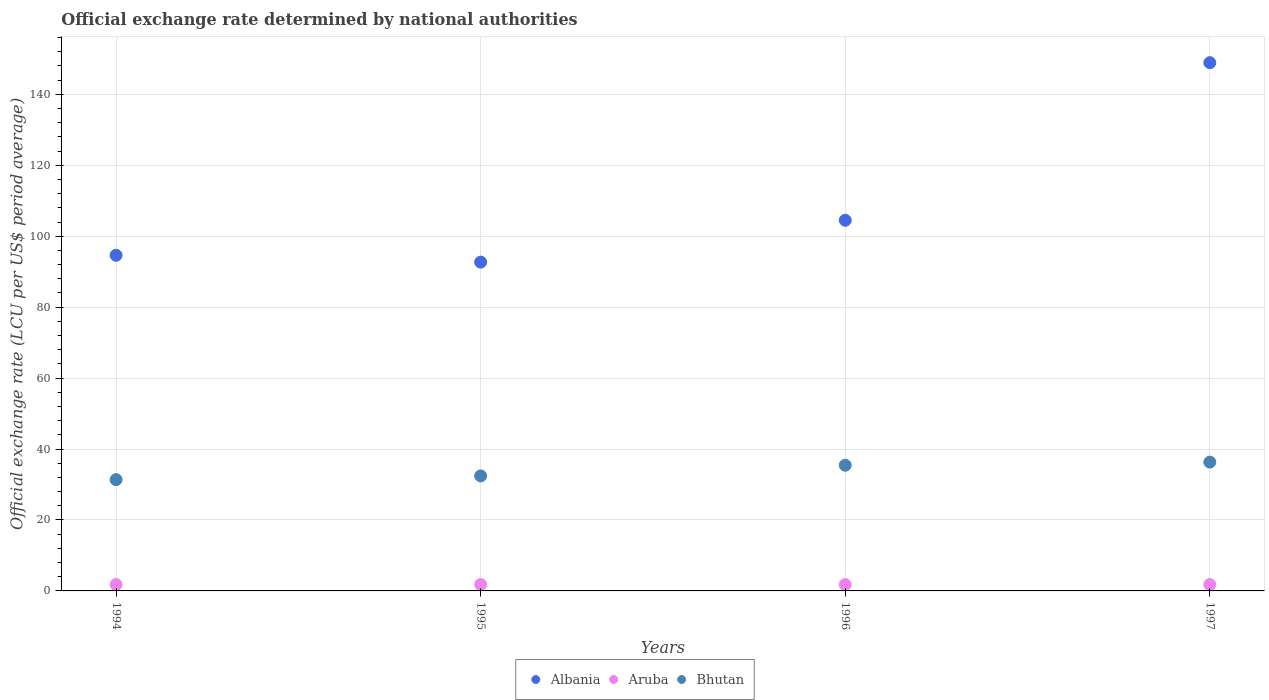How many different coloured dotlines are there?
Provide a succinct answer. 3. What is the official exchange rate in Aruba in 1997?
Your answer should be compact. 1.79. Across all years, what is the maximum official exchange rate in Bhutan?
Your response must be concise. 36.31. Across all years, what is the minimum official exchange rate in Aruba?
Your answer should be compact. 1.79. What is the total official exchange rate in Bhutan in the graph?
Offer a terse response. 135.55. What is the difference between the official exchange rate in Albania in 1995 and the official exchange rate in Aruba in 1996?
Offer a terse response. 90.91. What is the average official exchange rate in Bhutan per year?
Keep it short and to the point. 33.89. In the year 1996, what is the difference between the official exchange rate in Bhutan and official exchange rate in Albania?
Keep it short and to the point. -69.07. In how many years, is the official exchange rate in Bhutan greater than 8 LCU?
Provide a succinct answer. 4. What is the ratio of the official exchange rate in Albania in 1994 to that in 1996?
Your response must be concise. 0.91. Is the difference between the official exchange rate in Bhutan in 1994 and 1996 greater than the difference between the official exchange rate in Albania in 1994 and 1996?
Provide a short and direct response. Yes. What is the difference between the highest and the lowest official exchange rate in Albania?
Provide a succinct answer. 56.24. Is the official exchange rate in Aruba strictly less than the official exchange rate in Albania over the years?
Give a very brief answer. Yes. How many years are there in the graph?
Your answer should be very brief. 4. What is the difference between two consecutive major ticks on the Y-axis?
Your response must be concise. 20. Does the graph contain any zero values?
Offer a terse response. No. How are the legend labels stacked?
Your answer should be compact. Horizontal. What is the title of the graph?
Offer a very short reply. Official exchange rate determined by national authorities. Does "Mexico" appear as one of the legend labels in the graph?
Offer a very short reply. No. What is the label or title of the Y-axis?
Your response must be concise. Official exchange rate (LCU per US$ period average). What is the Official exchange rate (LCU per US$ period average) in Albania in 1994?
Ensure brevity in your answer.  94.62. What is the Official exchange rate (LCU per US$ period average) in Aruba in 1994?
Ensure brevity in your answer.  1.79. What is the Official exchange rate (LCU per US$ period average) of Bhutan in 1994?
Your answer should be compact. 31.37. What is the Official exchange rate (LCU per US$ period average) of Albania in 1995?
Provide a short and direct response. 92.7. What is the Official exchange rate (LCU per US$ period average) of Aruba in 1995?
Provide a succinct answer. 1.79. What is the Official exchange rate (LCU per US$ period average) of Bhutan in 1995?
Your response must be concise. 32.43. What is the Official exchange rate (LCU per US$ period average) of Albania in 1996?
Your response must be concise. 104.5. What is the Official exchange rate (LCU per US$ period average) in Aruba in 1996?
Your answer should be compact. 1.79. What is the Official exchange rate (LCU per US$ period average) in Bhutan in 1996?
Provide a short and direct response. 35.43. What is the Official exchange rate (LCU per US$ period average) in Albania in 1997?
Ensure brevity in your answer.  148.93. What is the Official exchange rate (LCU per US$ period average) of Aruba in 1997?
Give a very brief answer. 1.79. What is the Official exchange rate (LCU per US$ period average) of Bhutan in 1997?
Make the answer very short. 36.31. Across all years, what is the maximum Official exchange rate (LCU per US$ period average) in Albania?
Offer a very short reply. 148.93. Across all years, what is the maximum Official exchange rate (LCU per US$ period average) in Aruba?
Offer a very short reply. 1.79. Across all years, what is the maximum Official exchange rate (LCU per US$ period average) of Bhutan?
Make the answer very short. 36.31. Across all years, what is the minimum Official exchange rate (LCU per US$ period average) in Albania?
Provide a succinct answer. 92.7. Across all years, what is the minimum Official exchange rate (LCU per US$ period average) in Aruba?
Keep it short and to the point. 1.79. Across all years, what is the minimum Official exchange rate (LCU per US$ period average) in Bhutan?
Give a very brief answer. 31.37. What is the total Official exchange rate (LCU per US$ period average) in Albania in the graph?
Offer a terse response. 440.75. What is the total Official exchange rate (LCU per US$ period average) in Aruba in the graph?
Provide a short and direct response. 7.16. What is the total Official exchange rate (LCU per US$ period average) in Bhutan in the graph?
Your answer should be compact. 135.55. What is the difference between the Official exchange rate (LCU per US$ period average) of Albania in 1994 and that in 1995?
Offer a very short reply. 1.93. What is the difference between the Official exchange rate (LCU per US$ period average) of Bhutan in 1994 and that in 1995?
Offer a very short reply. -1.05. What is the difference between the Official exchange rate (LCU per US$ period average) of Albania in 1994 and that in 1996?
Offer a very short reply. -9.88. What is the difference between the Official exchange rate (LCU per US$ period average) in Aruba in 1994 and that in 1996?
Provide a succinct answer. 0. What is the difference between the Official exchange rate (LCU per US$ period average) in Bhutan in 1994 and that in 1996?
Give a very brief answer. -4.06. What is the difference between the Official exchange rate (LCU per US$ period average) in Albania in 1994 and that in 1997?
Make the answer very short. -54.31. What is the difference between the Official exchange rate (LCU per US$ period average) of Bhutan in 1994 and that in 1997?
Offer a very short reply. -4.94. What is the difference between the Official exchange rate (LCU per US$ period average) in Albania in 1995 and that in 1996?
Your answer should be very brief. -11.8. What is the difference between the Official exchange rate (LCU per US$ period average) of Bhutan in 1995 and that in 1996?
Keep it short and to the point. -3.01. What is the difference between the Official exchange rate (LCU per US$ period average) of Albania in 1995 and that in 1997?
Your response must be concise. -56.24. What is the difference between the Official exchange rate (LCU per US$ period average) of Bhutan in 1995 and that in 1997?
Offer a very short reply. -3.89. What is the difference between the Official exchange rate (LCU per US$ period average) of Albania in 1996 and that in 1997?
Offer a very short reply. -44.43. What is the difference between the Official exchange rate (LCU per US$ period average) in Bhutan in 1996 and that in 1997?
Your response must be concise. -0.88. What is the difference between the Official exchange rate (LCU per US$ period average) of Albania in 1994 and the Official exchange rate (LCU per US$ period average) of Aruba in 1995?
Keep it short and to the point. 92.83. What is the difference between the Official exchange rate (LCU per US$ period average) in Albania in 1994 and the Official exchange rate (LCU per US$ period average) in Bhutan in 1995?
Your answer should be compact. 62.2. What is the difference between the Official exchange rate (LCU per US$ period average) of Aruba in 1994 and the Official exchange rate (LCU per US$ period average) of Bhutan in 1995?
Offer a terse response. -30.64. What is the difference between the Official exchange rate (LCU per US$ period average) of Albania in 1994 and the Official exchange rate (LCU per US$ period average) of Aruba in 1996?
Your answer should be compact. 92.83. What is the difference between the Official exchange rate (LCU per US$ period average) in Albania in 1994 and the Official exchange rate (LCU per US$ period average) in Bhutan in 1996?
Your answer should be compact. 59.19. What is the difference between the Official exchange rate (LCU per US$ period average) of Aruba in 1994 and the Official exchange rate (LCU per US$ period average) of Bhutan in 1996?
Your answer should be compact. -33.64. What is the difference between the Official exchange rate (LCU per US$ period average) of Albania in 1994 and the Official exchange rate (LCU per US$ period average) of Aruba in 1997?
Provide a short and direct response. 92.83. What is the difference between the Official exchange rate (LCU per US$ period average) of Albania in 1994 and the Official exchange rate (LCU per US$ period average) of Bhutan in 1997?
Offer a terse response. 58.31. What is the difference between the Official exchange rate (LCU per US$ period average) in Aruba in 1994 and the Official exchange rate (LCU per US$ period average) in Bhutan in 1997?
Give a very brief answer. -34.52. What is the difference between the Official exchange rate (LCU per US$ period average) of Albania in 1995 and the Official exchange rate (LCU per US$ period average) of Aruba in 1996?
Offer a very short reply. 90.91. What is the difference between the Official exchange rate (LCU per US$ period average) of Albania in 1995 and the Official exchange rate (LCU per US$ period average) of Bhutan in 1996?
Provide a succinct answer. 57.26. What is the difference between the Official exchange rate (LCU per US$ period average) of Aruba in 1995 and the Official exchange rate (LCU per US$ period average) of Bhutan in 1996?
Your answer should be very brief. -33.64. What is the difference between the Official exchange rate (LCU per US$ period average) of Albania in 1995 and the Official exchange rate (LCU per US$ period average) of Aruba in 1997?
Provide a succinct answer. 90.91. What is the difference between the Official exchange rate (LCU per US$ period average) in Albania in 1995 and the Official exchange rate (LCU per US$ period average) in Bhutan in 1997?
Ensure brevity in your answer.  56.38. What is the difference between the Official exchange rate (LCU per US$ period average) of Aruba in 1995 and the Official exchange rate (LCU per US$ period average) of Bhutan in 1997?
Your answer should be compact. -34.52. What is the difference between the Official exchange rate (LCU per US$ period average) in Albania in 1996 and the Official exchange rate (LCU per US$ period average) in Aruba in 1997?
Ensure brevity in your answer.  102.71. What is the difference between the Official exchange rate (LCU per US$ period average) in Albania in 1996 and the Official exchange rate (LCU per US$ period average) in Bhutan in 1997?
Offer a very short reply. 68.19. What is the difference between the Official exchange rate (LCU per US$ period average) in Aruba in 1996 and the Official exchange rate (LCU per US$ period average) in Bhutan in 1997?
Ensure brevity in your answer.  -34.52. What is the average Official exchange rate (LCU per US$ period average) of Albania per year?
Offer a terse response. 110.19. What is the average Official exchange rate (LCU per US$ period average) in Aruba per year?
Give a very brief answer. 1.79. What is the average Official exchange rate (LCU per US$ period average) in Bhutan per year?
Offer a very short reply. 33.89. In the year 1994, what is the difference between the Official exchange rate (LCU per US$ period average) of Albania and Official exchange rate (LCU per US$ period average) of Aruba?
Provide a succinct answer. 92.83. In the year 1994, what is the difference between the Official exchange rate (LCU per US$ period average) in Albania and Official exchange rate (LCU per US$ period average) in Bhutan?
Offer a very short reply. 63.25. In the year 1994, what is the difference between the Official exchange rate (LCU per US$ period average) of Aruba and Official exchange rate (LCU per US$ period average) of Bhutan?
Offer a very short reply. -29.58. In the year 1995, what is the difference between the Official exchange rate (LCU per US$ period average) in Albania and Official exchange rate (LCU per US$ period average) in Aruba?
Offer a terse response. 90.91. In the year 1995, what is the difference between the Official exchange rate (LCU per US$ period average) of Albania and Official exchange rate (LCU per US$ period average) of Bhutan?
Provide a short and direct response. 60.27. In the year 1995, what is the difference between the Official exchange rate (LCU per US$ period average) in Aruba and Official exchange rate (LCU per US$ period average) in Bhutan?
Give a very brief answer. -30.64. In the year 1996, what is the difference between the Official exchange rate (LCU per US$ period average) in Albania and Official exchange rate (LCU per US$ period average) in Aruba?
Offer a terse response. 102.71. In the year 1996, what is the difference between the Official exchange rate (LCU per US$ period average) in Albania and Official exchange rate (LCU per US$ period average) in Bhutan?
Offer a very short reply. 69.07. In the year 1996, what is the difference between the Official exchange rate (LCU per US$ period average) in Aruba and Official exchange rate (LCU per US$ period average) in Bhutan?
Ensure brevity in your answer.  -33.64. In the year 1997, what is the difference between the Official exchange rate (LCU per US$ period average) of Albania and Official exchange rate (LCU per US$ period average) of Aruba?
Your answer should be very brief. 147.14. In the year 1997, what is the difference between the Official exchange rate (LCU per US$ period average) of Albania and Official exchange rate (LCU per US$ period average) of Bhutan?
Offer a terse response. 112.62. In the year 1997, what is the difference between the Official exchange rate (LCU per US$ period average) in Aruba and Official exchange rate (LCU per US$ period average) in Bhutan?
Offer a very short reply. -34.52. What is the ratio of the Official exchange rate (LCU per US$ period average) in Albania in 1994 to that in 1995?
Make the answer very short. 1.02. What is the ratio of the Official exchange rate (LCU per US$ period average) in Bhutan in 1994 to that in 1995?
Offer a terse response. 0.97. What is the ratio of the Official exchange rate (LCU per US$ period average) in Albania in 1994 to that in 1996?
Give a very brief answer. 0.91. What is the ratio of the Official exchange rate (LCU per US$ period average) of Bhutan in 1994 to that in 1996?
Make the answer very short. 0.89. What is the ratio of the Official exchange rate (LCU per US$ period average) in Albania in 1994 to that in 1997?
Provide a short and direct response. 0.64. What is the ratio of the Official exchange rate (LCU per US$ period average) of Aruba in 1994 to that in 1997?
Keep it short and to the point. 1. What is the ratio of the Official exchange rate (LCU per US$ period average) in Bhutan in 1994 to that in 1997?
Provide a short and direct response. 0.86. What is the ratio of the Official exchange rate (LCU per US$ period average) in Albania in 1995 to that in 1996?
Make the answer very short. 0.89. What is the ratio of the Official exchange rate (LCU per US$ period average) of Bhutan in 1995 to that in 1996?
Make the answer very short. 0.92. What is the ratio of the Official exchange rate (LCU per US$ period average) in Albania in 1995 to that in 1997?
Provide a short and direct response. 0.62. What is the ratio of the Official exchange rate (LCU per US$ period average) in Aruba in 1995 to that in 1997?
Make the answer very short. 1. What is the ratio of the Official exchange rate (LCU per US$ period average) in Bhutan in 1995 to that in 1997?
Your answer should be compact. 0.89. What is the ratio of the Official exchange rate (LCU per US$ period average) of Albania in 1996 to that in 1997?
Your answer should be very brief. 0.7. What is the ratio of the Official exchange rate (LCU per US$ period average) in Bhutan in 1996 to that in 1997?
Your response must be concise. 0.98. What is the difference between the highest and the second highest Official exchange rate (LCU per US$ period average) in Albania?
Your answer should be compact. 44.43. What is the difference between the highest and the second highest Official exchange rate (LCU per US$ period average) in Bhutan?
Your answer should be compact. 0.88. What is the difference between the highest and the lowest Official exchange rate (LCU per US$ period average) of Albania?
Ensure brevity in your answer.  56.24. What is the difference between the highest and the lowest Official exchange rate (LCU per US$ period average) of Bhutan?
Provide a succinct answer. 4.94. 